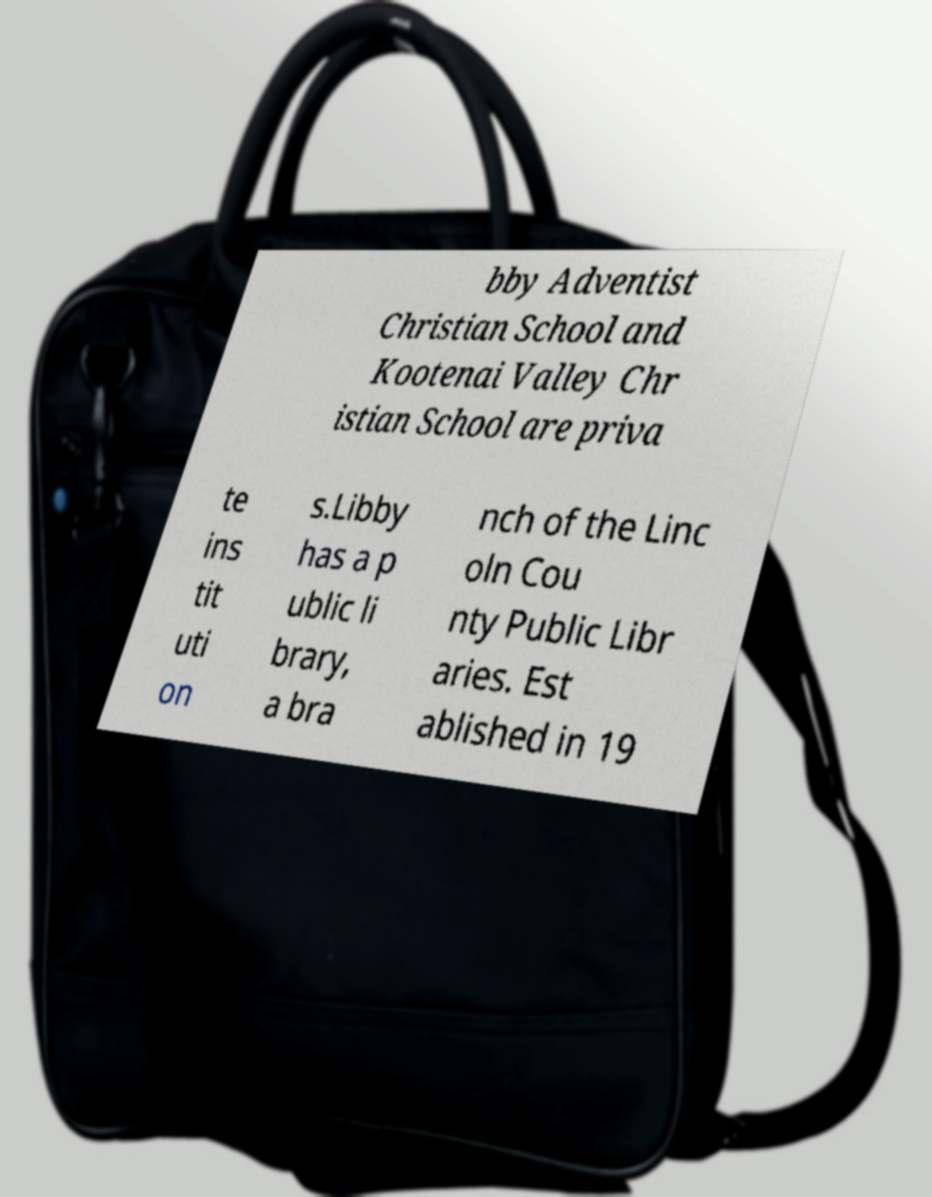Can you read and provide the text displayed in the image?This photo seems to have some interesting text. Can you extract and type it out for me? bby Adventist Christian School and Kootenai Valley Chr istian School are priva te ins tit uti on s.Libby has a p ublic li brary, a bra nch of the Linc oln Cou nty Public Libr aries. Est ablished in 19 